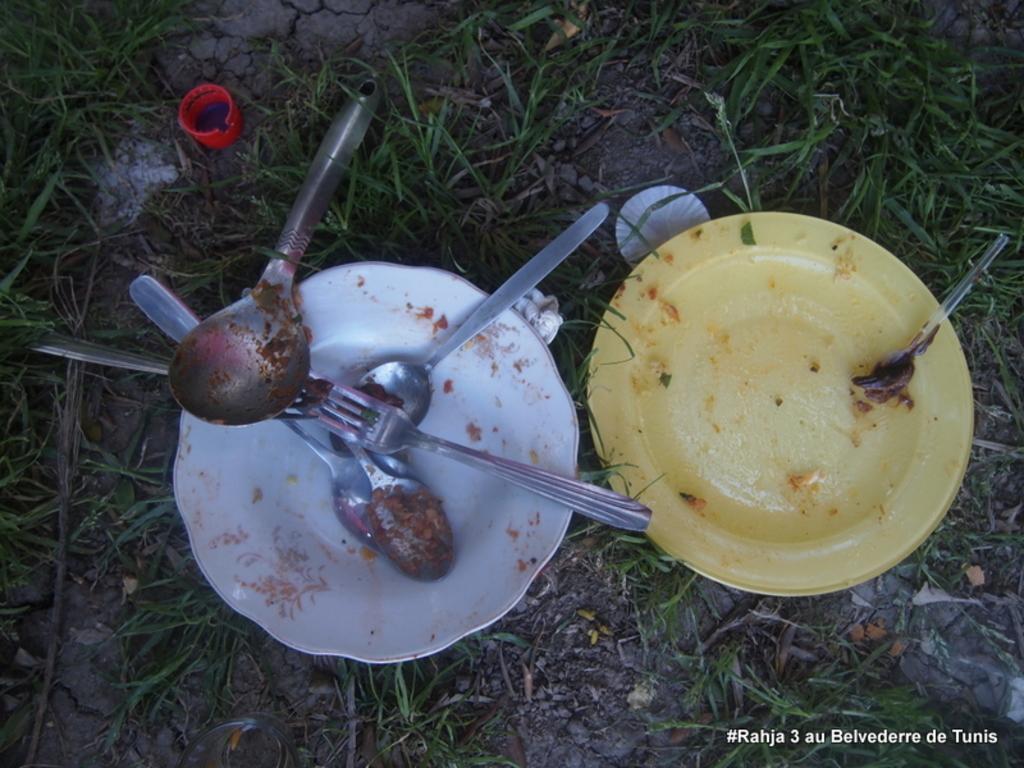In one or two sentences, can you explain what this image depicts? In the picture I can see forks, spoons, plates, the grass and some other objects. 